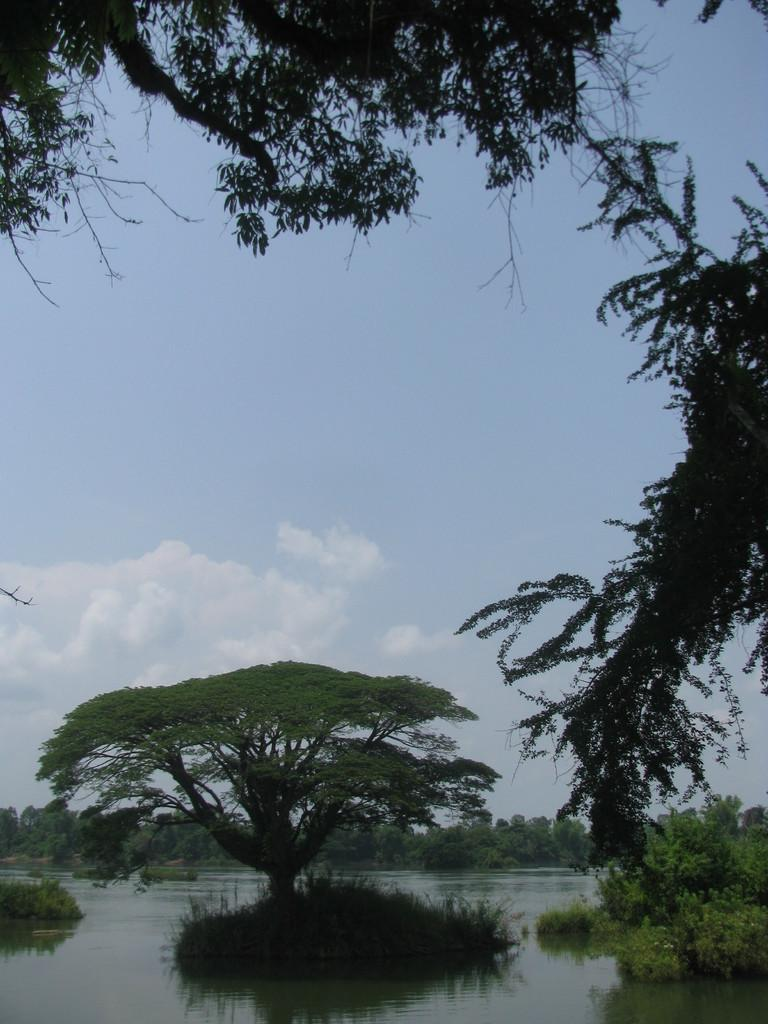What is located on the water in the image? There are trees on the water in the image. How many trees can be seen in the background of the image? There are many trees visible in the background of the image. What can be seen in the sky in the background of the image? Clouds are present in the background of the image, and the sky is blue. What type of expansion is visible in the image? There is no expansion visible in the image; it features trees on the water and a blue sky with clouds. Can you see a bat flying in the image? There is no bat present in the image. 